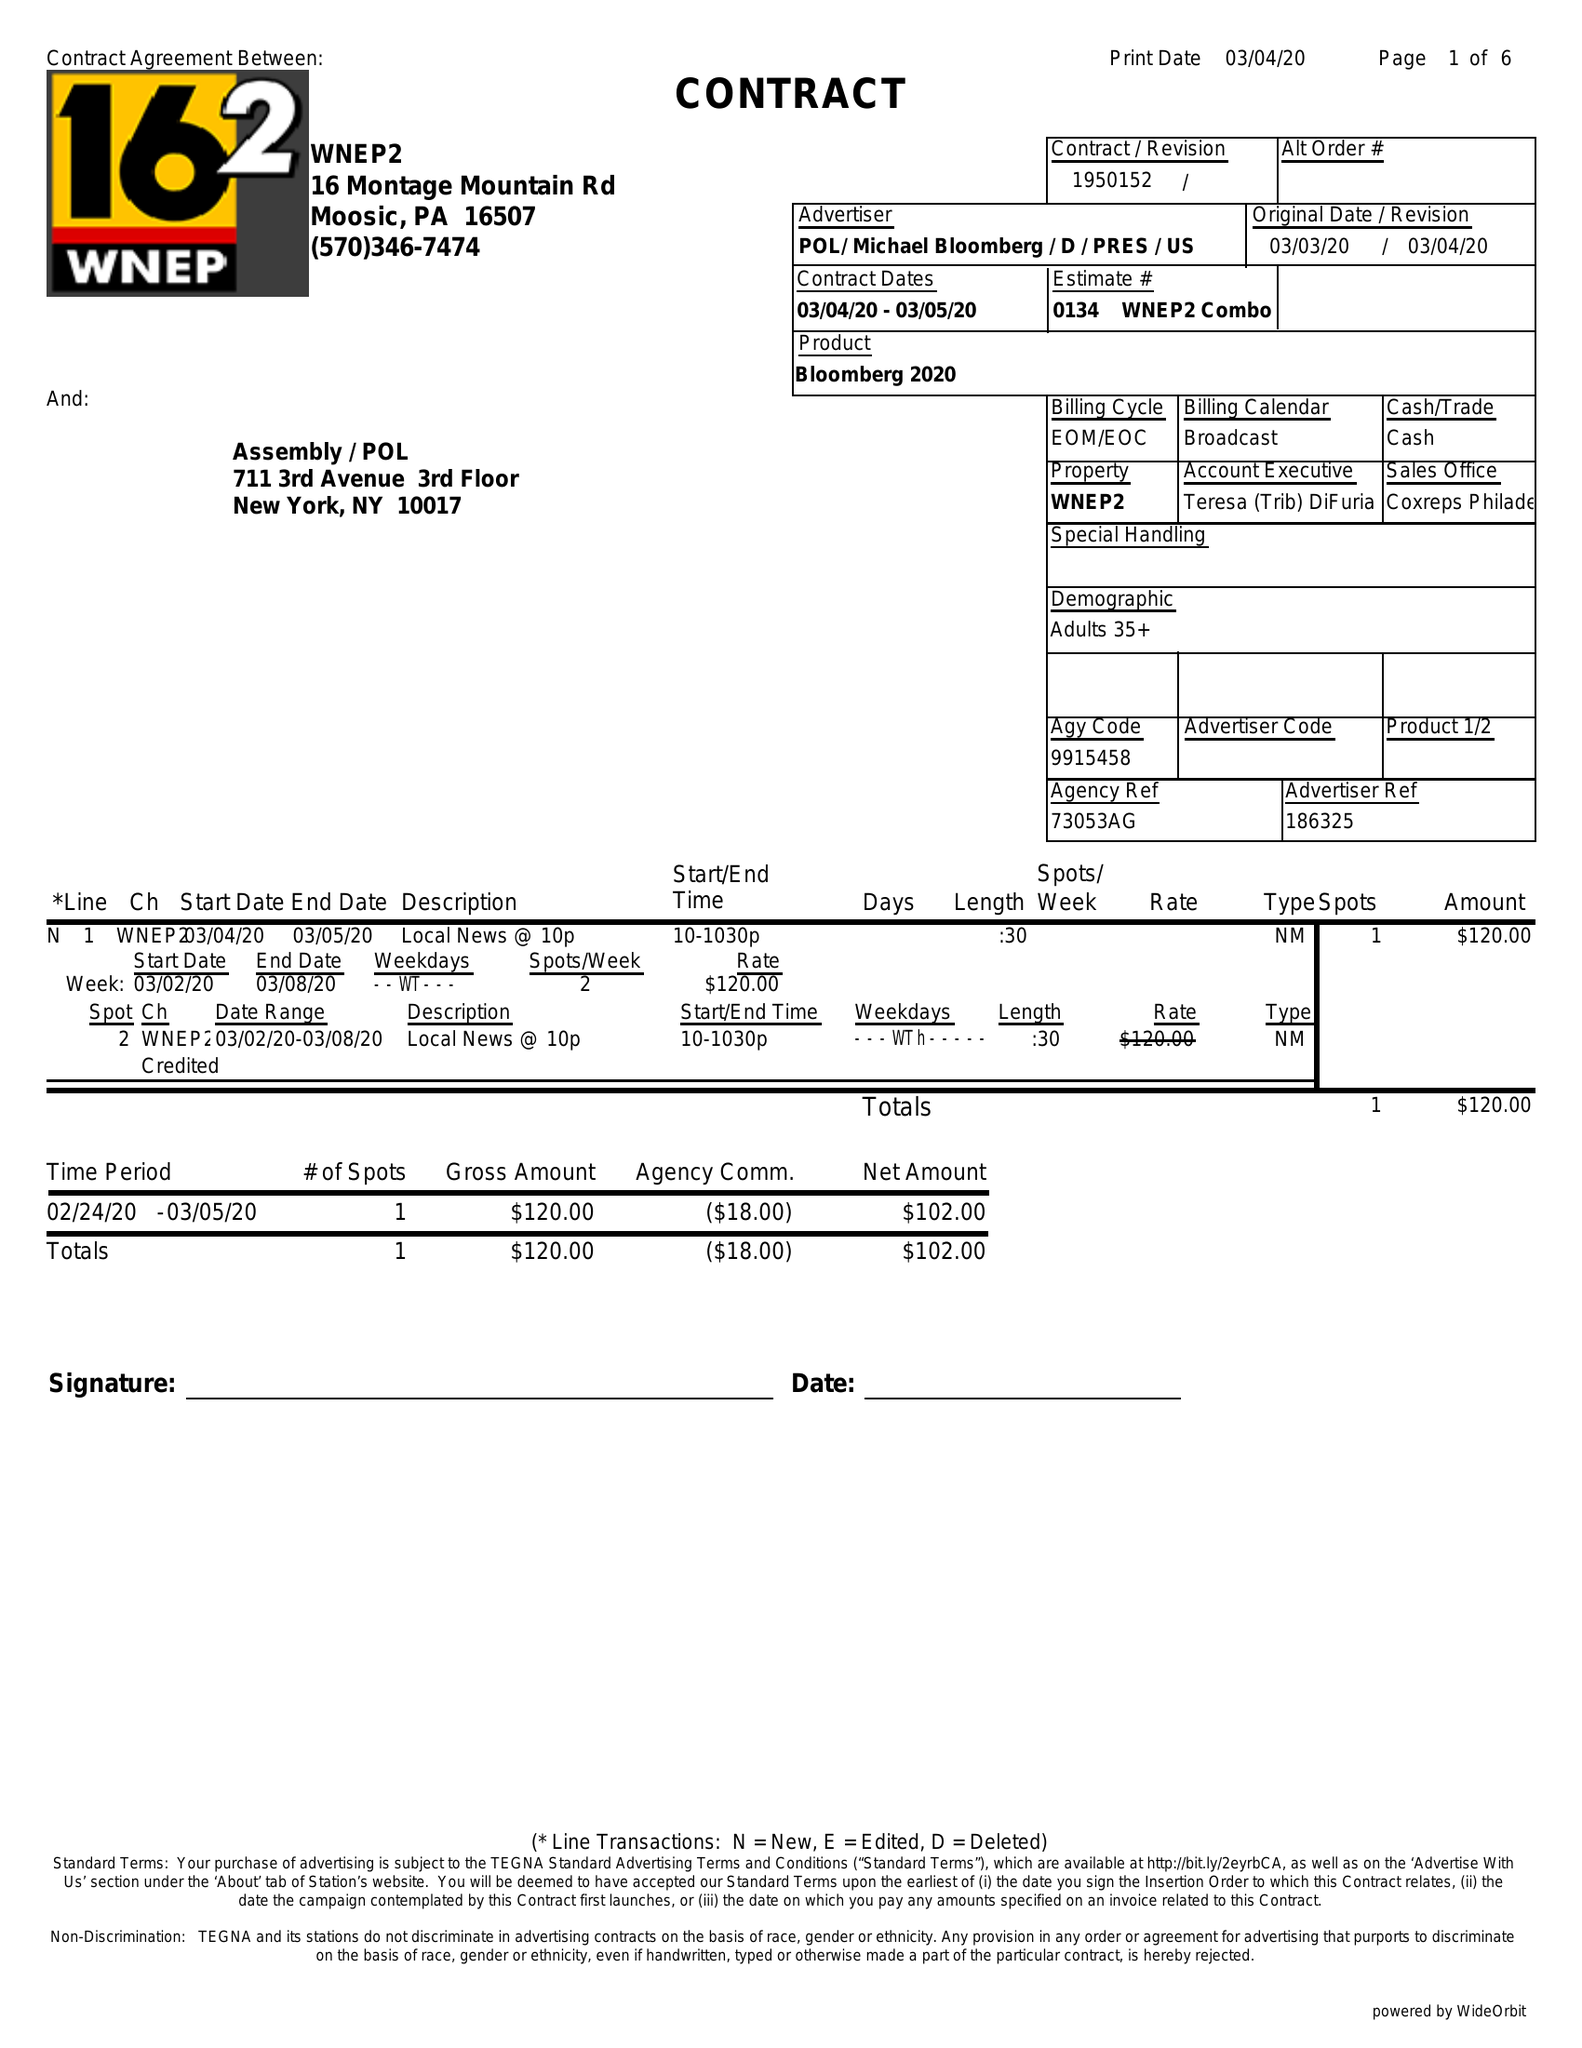What is the value for the flight_to?
Answer the question using a single word or phrase. 03/05/20 